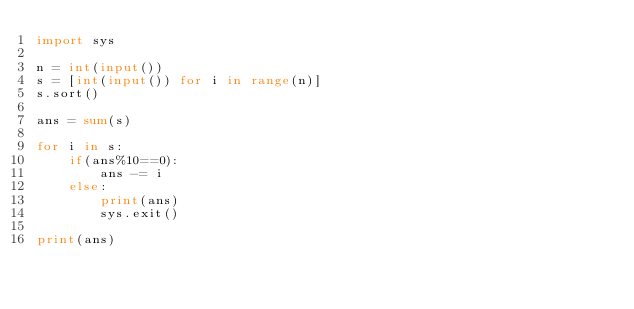Convert code to text. <code><loc_0><loc_0><loc_500><loc_500><_Python_>import sys

n = int(input())
s = [int(input()) for i in range(n)]
s.sort()

ans = sum(s)

for i in s:
	if(ans%10==0):
		ans -= i
	else:
		print(ans)
		sys.exit()

print(ans)</code> 